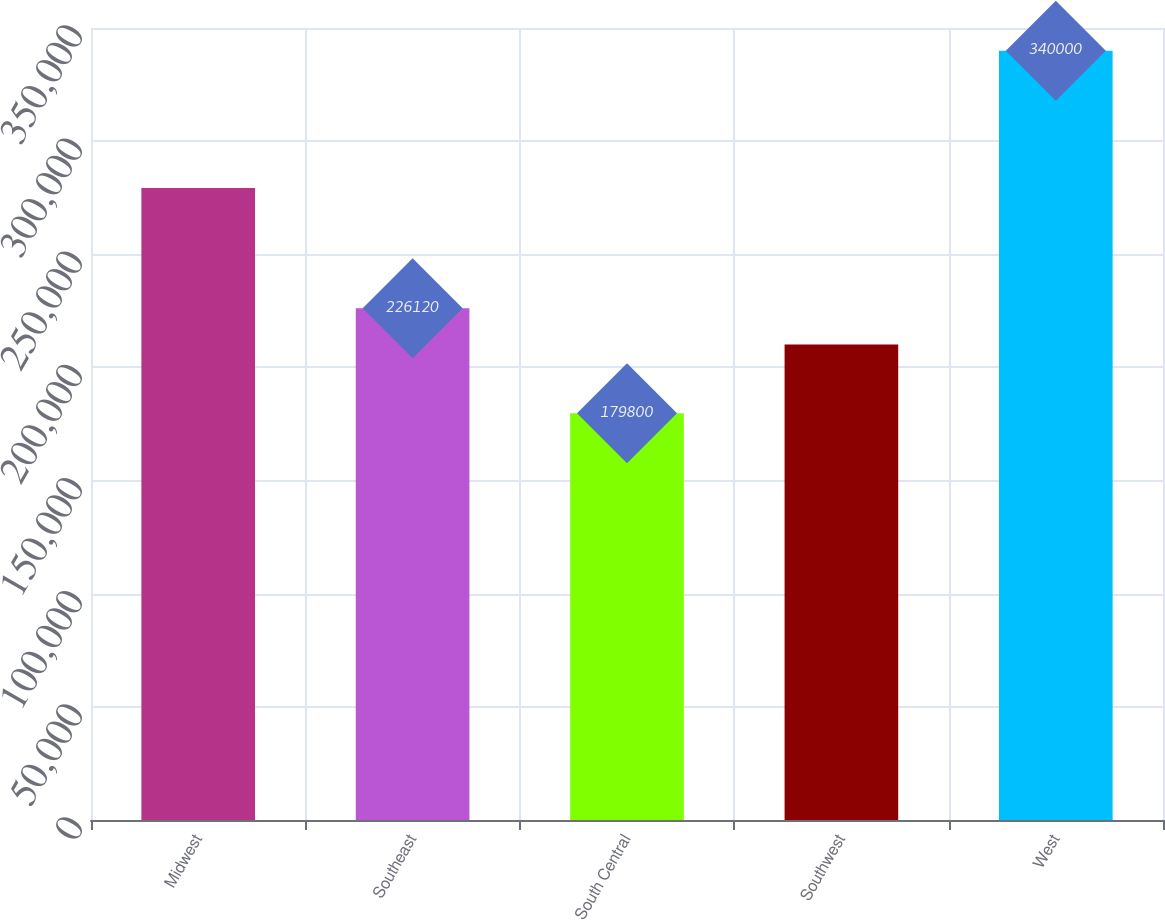<chart> <loc_0><loc_0><loc_500><loc_500><bar_chart><fcel>Midwest<fcel>Southeast<fcel>South Central<fcel>Southwest<fcel>West<nl><fcel>279300<fcel>226120<fcel>179800<fcel>210100<fcel>340000<nl></chart> 